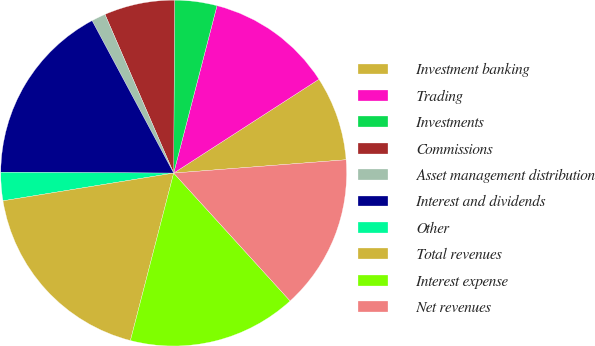Convert chart to OTSL. <chart><loc_0><loc_0><loc_500><loc_500><pie_chart><fcel>Investment banking<fcel>Trading<fcel>Investments<fcel>Commissions<fcel>Asset management distribution<fcel>Interest and dividends<fcel>Other<fcel>Total revenues<fcel>Interest expense<fcel>Net revenues<nl><fcel>7.9%<fcel>11.84%<fcel>3.95%<fcel>6.58%<fcel>1.32%<fcel>17.1%<fcel>2.64%<fcel>18.41%<fcel>15.78%<fcel>14.47%<nl></chart> 